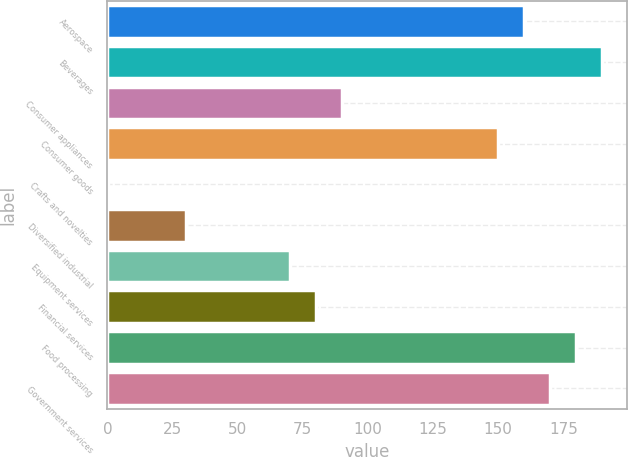Convert chart to OTSL. <chart><loc_0><loc_0><loc_500><loc_500><bar_chart><fcel>Aerospace<fcel>Beverages<fcel>Consumer appliances<fcel>Consumer goods<fcel>Crafts and novelties<fcel>Diversified industrial<fcel>Equipment services<fcel>Financial services<fcel>Food processing<fcel>Government services<nl><fcel>159.94<fcel>189.91<fcel>90.01<fcel>149.95<fcel>0.1<fcel>30.07<fcel>70.03<fcel>80.02<fcel>179.92<fcel>169.93<nl></chart> 